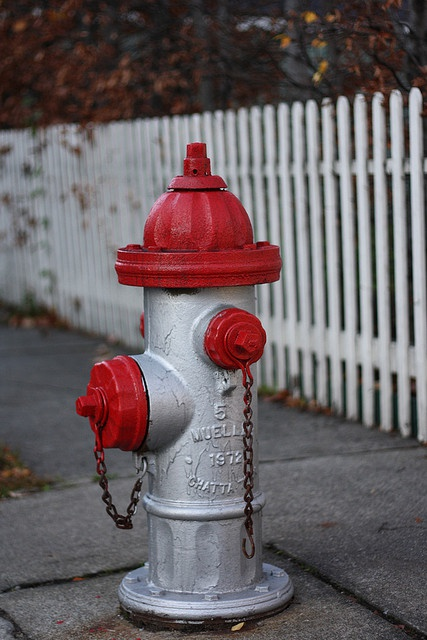Describe the objects in this image and their specific colors. I can see a fire hydrant in maroon, darkgray, gray, and brown tones in this image. 